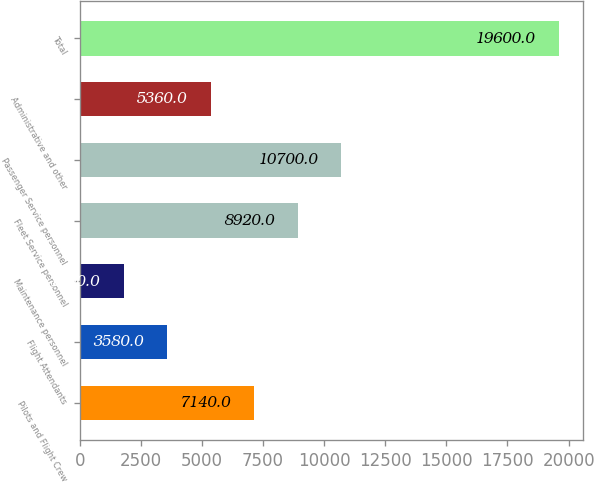<chart> <loc_0><loc_0><loc_500><loc_500><bar_chart><fcel>Pilots and Flight Crew<fcel>Flight Attendants<fcel>Maintenance personnel<fcel>Fleet Service personnel<fcel>Passenger Service personnel<fcel>Administrative and other<fcel>Total<nl><fcel>7140<fcel>3580<fcel>1800<fcel>8920<fcel>10700<fcel>5360<fcel>19600<nl></chart> 